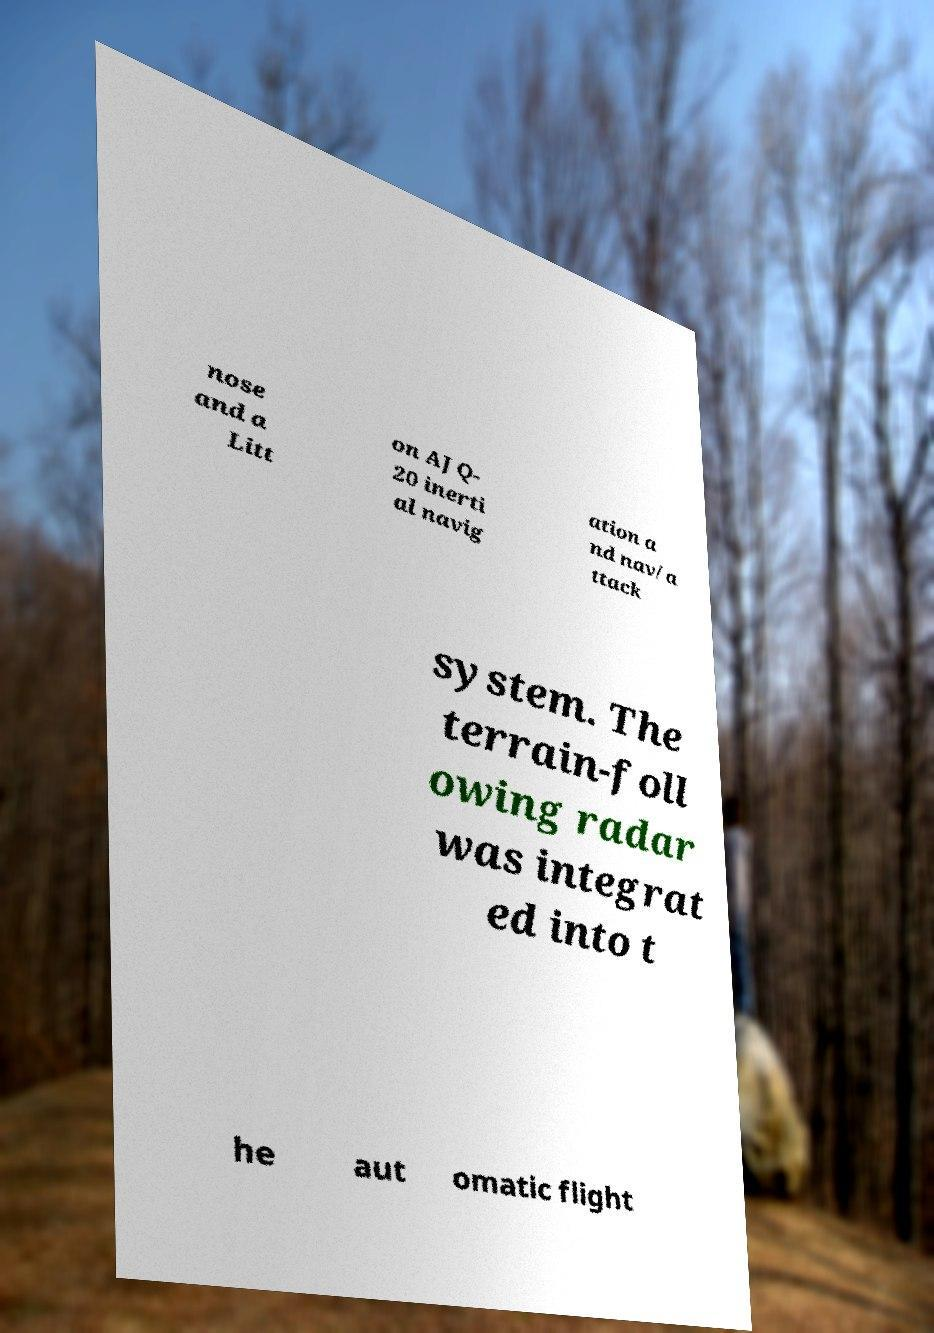Could you assist in decoding the text presented in this image and type it out clearly? nose and a Litt on AJQ- 20 inerti al navig ation a nd nav/a ttack system. The terrain-foll owing radar was integrat ed into t he aut omatic flight 